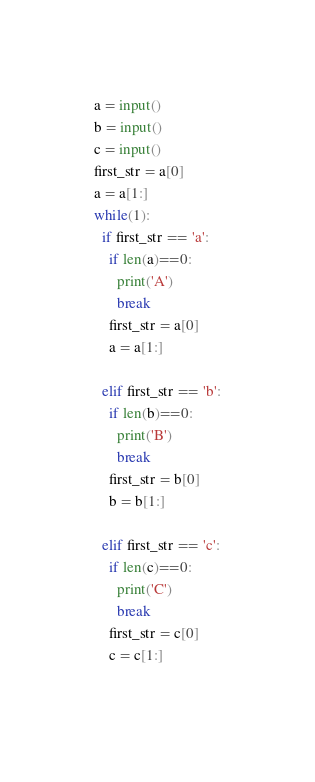<code> <loc_0><loc_0><loc_500><loc_500><_Python_>a = input()
b = input()
c = input()
first_str = a[0]
a = a[1:]
while(1):
  if first_str == 'a':
    if len(a)==0:
      print('A')
      break
    first_str = a[0]
    a = a[1:]
    
  elif first_str == 'b':
    if len(b)==0:
      print('B')
      break
    first_str = b[0]
    b = b[1:]
    
  elif first_str == 'c':
    if len(c)==0:
      print('C')
      break
    first_str = c[0]
    c = c[1:]
    </code> 